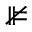<formula> <loc_0><loc_0><loc_500><loc_500>\nVDash</formula> 